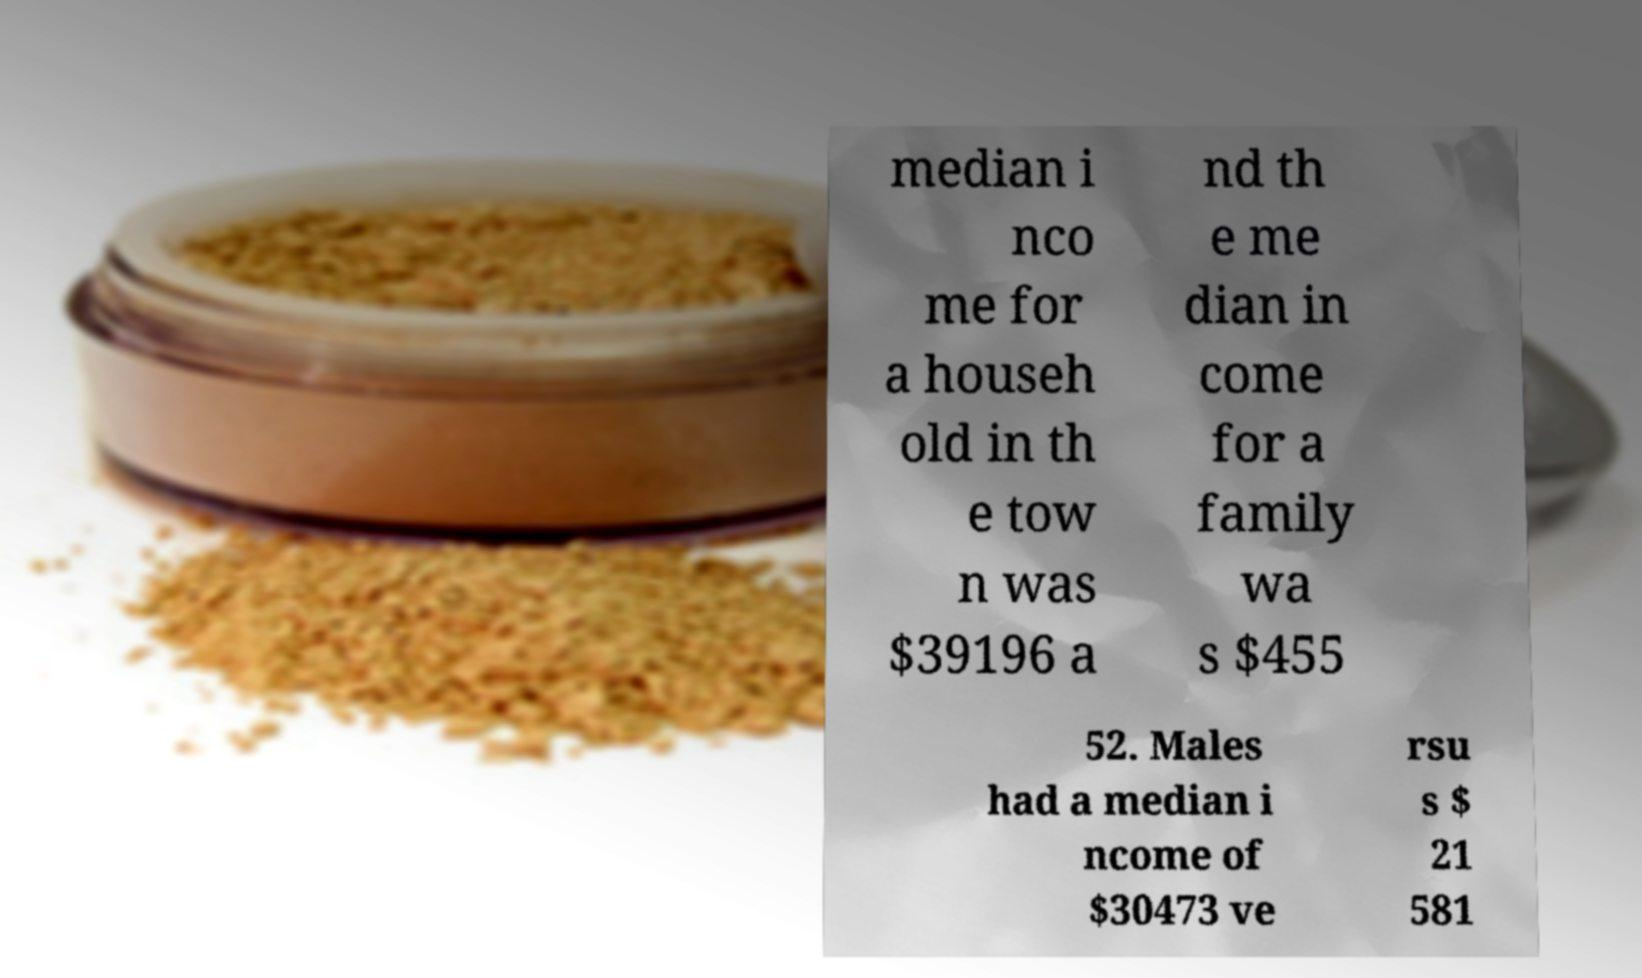There's text embedded in this image that I need extracted. Can you transcribe it verbatim? median i nco me for a househ old in th e tow n was $39196 a nd th e me dian in come for a family wa s $455 52. Males had a median i ncome of $30473 ve rsu s $ 21 581 